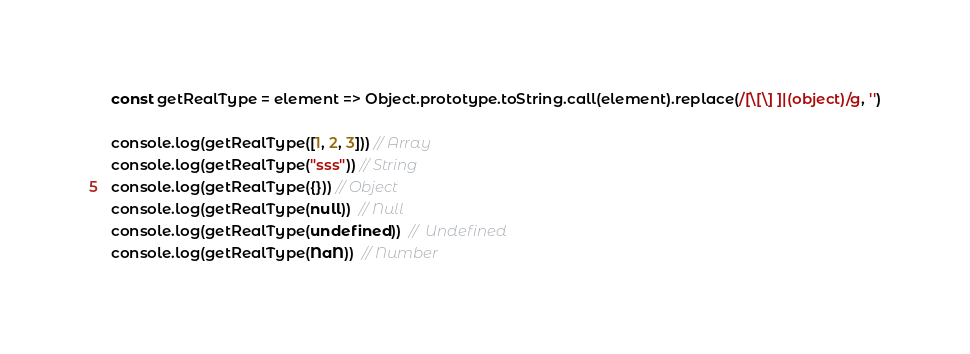<code> <loc_0><loc_0><loc_500><loc_500><_JavaScript_>const getRealType = element => Object.prototype.toString.call(element).replace(/[\[\] ]|(object)/g, '')

console.log(getRealType([1, 2, 3])) // Array
console.log(getRealType("sss")) // String
console.log(getRealType({})) // Object
console.log(getRealType(null))  // Null
console.log(getRealType(undefined))  //  Undefined
console.log(getRealType(NaN))  // Number

</code> 